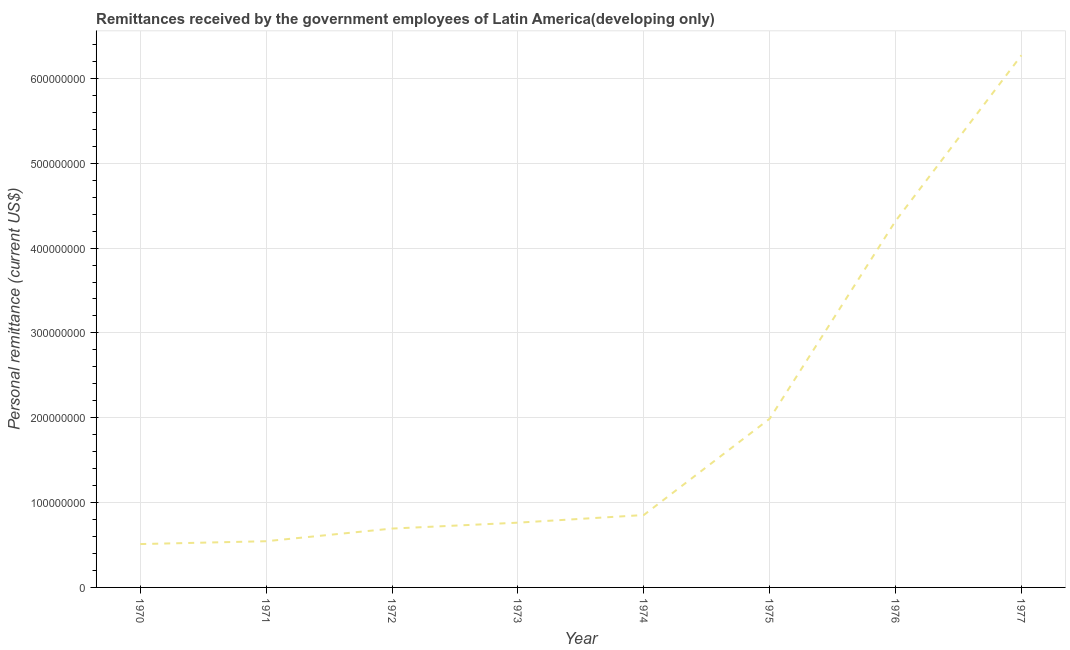What is the personal remittances in 1970?
Offer a terse response. 5.11e+07. Across all years, what is the maximum personal remittances?
Provide a short and direct response. 6.27e+08. Across all years, what is the minimum personal remittances?
Your answer should be very brief. 5.11e+07. In which year was the personal remittances minimum?
Your answer should be compact. 1970. What is the sum of the personal remittances?
Offer a terse response. 1.59e+09. What is the difference between the personal remittances in 1972 and 1974?
Your answer should be very brief. -1.60e+07. What is the average personal remittances per year?
Your answer should be compact. 1.99e+08. What is the median personal remittances?
Your answer should be very brief. 8.08e+07. In how many years, is the personal remittances greater than 300000000 US$?
Keep it short and to the point. 2. Do a majority of the years between 1971 and 1972 (inclusive) have personal remittances greater than 260000000 US$?
Ensure brevity in your answer.  No. What is the ratio of the personal remittances in 1972 to that in 1975?
Your answer should be compact. 0.35. Is the difference between the personal remittances in 1975 and 1976 greater than the difference between any two years?
Give a very brief answer. No. What is the difference between the highest and the second highest personal remittances?
Make the answer very short. 1.95e+08. What is the difference between the highest and the lowest personal remittances?
Make the answer very short. 5.76e+08. How many lines are there?
Keep it short and to the point. 1. How many years are there in the graph?
Ensure brevity in your answer.  8. Does the graph contain any zero values?
Offer a very short reply. No. Does the graph contain grids?
Offer a terse response. Yes. What is the title of the graph?
Offer a very short reply. Remittances received by the government employees of Latin America(developing only). What is the label or title of the Y-axis?
Keep it short and to the point. Personal remittance (current US$). What is the Personal remittance (current US$) of 1970?
Offer a terse response. 5.11e+07. What is the Personal remittance (current US$) of 1971?
Offer a very short reply. 5.45e+07. What is the Personal remittance (current US$) of 1972?
Offer a very short reply. 6.94e+07. What is the Personal remittance (current US$) in 1973?
Provide a short and direct response. 7.63e+07. What is the Personal remittance (current US$) of 1974?
Ensure brevity in your answer.  8.53e+07. What is the Personal remittance (current US$) in 1975?
Make the answer very short. 1.99e+08. What is the Personal remittance (current US$) of 1976?
Provide a short and direct response. 4.32e+08. What is the Personal remittance (current US$) in 1977?
Ensure brevity in your answer.  6.27e+08. What is the difference between the Personal remittance (current US$) in 1970 and 1971?
Keep it short and to the point. -3.37e+06. What is the difference between the Personal remittance (current US$) in 1970 and 1972?
Give a very brief answer. -1.83e+07. What is the difference between the Personal remittance (current US$) in 1970 and 1973?
Give a very brief answer. -2.52e+07. What is the difference between the Personal remittance (current US$) in 1970 and 1974?
Ensure brevity in your answer.  -3.42e+07. What is the difference between the Personal remittance (current US$) in 1970 and 1975?
Your answer should be compact. -1.48e+08. What is the difference between the Personal remittance (current US$) in 1970 and 1976?
Make the answer very short. -3.81e+08. What is the difference between the Personal remittance (current US$) in 1970 and 1977?
Your answer should be very brief. -5.76e+08. What is the difference between the Personal remittance (current US$) in 1971 and 1972?
Offer a very short reply. -1.49e+07. What is the difference between the Personal remittance (current US$) in 1971 and 1973?
Provide a succinct answer. -2.19e+07. What is the difference between the Personal remittance (current US$) in 1971 and 1974?
Offer a very short reply. -3.09e+07. What is the difference between the Personal remittance (current US$) in 1971 and 1975?
Offer a terse response. -1.44e+08. What is the difference between the Personal remittance (current US$) in 1971 and 1976?
Offer a terse response. -3.77e+08. What is the difference between the Personal remittance (current US$) in 1971 and 1977?
Provide a short and direct response. -5.73e+08. What is the difference between the Personal remittance (current US$) in 1972 and 1973?
Make the answer very short. -6.96e+06. What is the difference between the Personal remittance (current US$) in 1972 and 1974?
Your answer should be compact. -1.60e+07. What is the difference between the Personal remittance (current US$) in 1972 and 1975?
Make the answer very short. -1.29e+08. What is the difference between the Personal remittance (current US$) in 1972 and 1976?
Make the answer very short. -3.63e+08. What is the difference between the Personal remittance (current US$) in 1972 and 1977?
Provide a succinct answer. -5.58e+08. What is the difference between the Personal remittance (current US$) in 1973 and 1974?
Your response must be concise. -9.00e+06. What is the difference between the Personal remittance (current US$) in 1973 and 1975?
Ensure brevity in your answer.  -1.23e+08. What is the difference between the Personal remittance (current US$) in 1973 and 1976?
Provide a short and direct response. -3.56e+08. What is the difference between the Personal remittance (current US$) in 1973 and 1977?
Keep it short and to the point. -5.51e+08. What is the difference between the Personal remittance (current US$) in 1974 and 1975?
Offer a terse response. -1.14e+08. What is the difference between the Personal remittance (current US$) in 1974 and 1976?
Your answer should be compact. -3.47e+08. What is the difference between the Personal remittance (current US$) in 1974 and 1977?
Keep it short and to the point. -5.42e+08. What is the difference between the Personal remittance (current US$) in 1975 and 1976?
Offer a terse response. -2.33e+08. What is the difference between the Personal remittance (current US$) in 1975 and 1977?
Keep it short and to the point. -4.28e+08. What is the difference between the Personal remittance (current US$) in 1976 and 1977?
Your answer should be compact. -1.95e+08. What is the ratio of the Personal remittance (current US$) in 1970 to that in 1971?
Offer a very short reply. 0.94. What is the ratio of the Personal remittance (current US$) in 1970 to that in 1972?
Your answer should be compact. 0.74. What is the ratio of the Personal remittance (current US$) in 1970 to that in 1973?
Provide a succinct answer. 0.67. What is the ratio of the Personal remittance (current US$) in 1970 to that in 1974?
Ensure brevity in your answer.  0.6. What is the ratio of the Personal remittance (current US$) in 1970 to that in 1975?
Keep it short and to the point. 0.26. What is the ratio of the Personal remittance (current US$) in 1970 to that in 1976?
Your answer should be very brief. 0.12. What is the ratio of the Personal remittance (current US$) in 1970 to that in 1977?
Provide a short and direct response. 0.08. What is the ratio of the Personal remittance (current US$) in 1971 to that in 1972?
Your answer should be compact. 0.79. What is the ratio of the Personal remittance (current US$) in 1971 to that in 1973?
Give a very brief answer. 0.71. What is the ratio of the Personal remittance (current US$) in 1971 to that in 1974?
Offer a very short reply. 0.64. What is the ratio of the Personal remittance (current US$) in 1971 to that in 1975?
Make the answer very short. 0.27. What is the ratio of the Personal remittance (current US$) in 1971 to that in 1976?
Give a very brief answer. 0.13. What is the ratio of the Personal remittance (current US$) in 1971 to that in 1977?
Offer a very short reply. 0.09. What is the ratio of the Personal remittance (current US$) in 1972 to that in 1973?
Your answer should be compact. 0.91. What is the ratio of the Personal remittance (current US$) in 1972 to that in 1974?
Your response must be concise. 0.81. What is the ratio of the Personal remittance (current US$) in 1972 to that in 1975?
Provide a short and direct response. 0.35. What is the ratio of the Personal remittance (current US$) in 1972 to that in 1976?
Provide a short and direct response. 0.16. What is the ratio of the Personal remittance (current US$) in 1972 to that in 1977?
Provide a succinct answer. 0.11. What is the ratio of the Personal remittance (current US$) in 1973 to that in 1974?
Make the answer very short. 0.9. What is the ratio of the Personal remittance (current US$) in 1973 to that in 1975?
Your response must be concise. 0.38. What is the ratio of the Personal remittance (current US$) in 1973 to that in 1976?
Give a very brief answer. 0.18. What is the ratio of the Personal remittance (current US$) in 1973 to that in 1977?
Your response must be concise. 0.12. What is the ratio of the Personal remittance (current US$) in 1974 to that in 1975?
Ensure brevity in your answer.  0.43. What is the ratio of the Personal remittance (current US$) in 1974 to that in 1976?
Give a very brief answer. 0.2. What is the ratio of the Personal remittance (current US$) in 1974 to that in 1977?
Keep it short and to the point. 0.14. What is the ratio of the Personal remittance (current US$) in 1975 to that in 1976?
Make the answer very short. 0.46. What is the ratio of the Personal remittance (current US$) in 1975 to that in 1977?
Your answer should be very brief. 0.32. What is the ratio of the Personal remittance (current US$) in 1976 to that in 1977?
Offer a terse response. 0.69. 